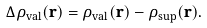<formula> <loc_0><loc_0><loc_500><loc_500>\Delta \rho _ { \text {val} } ( { \mathbf r } ) = \rho _ { \text {val} } ( { \mathbf r } ) - \rho _ { \text {sup} } ( { \mathbf r } ) .</formula> 